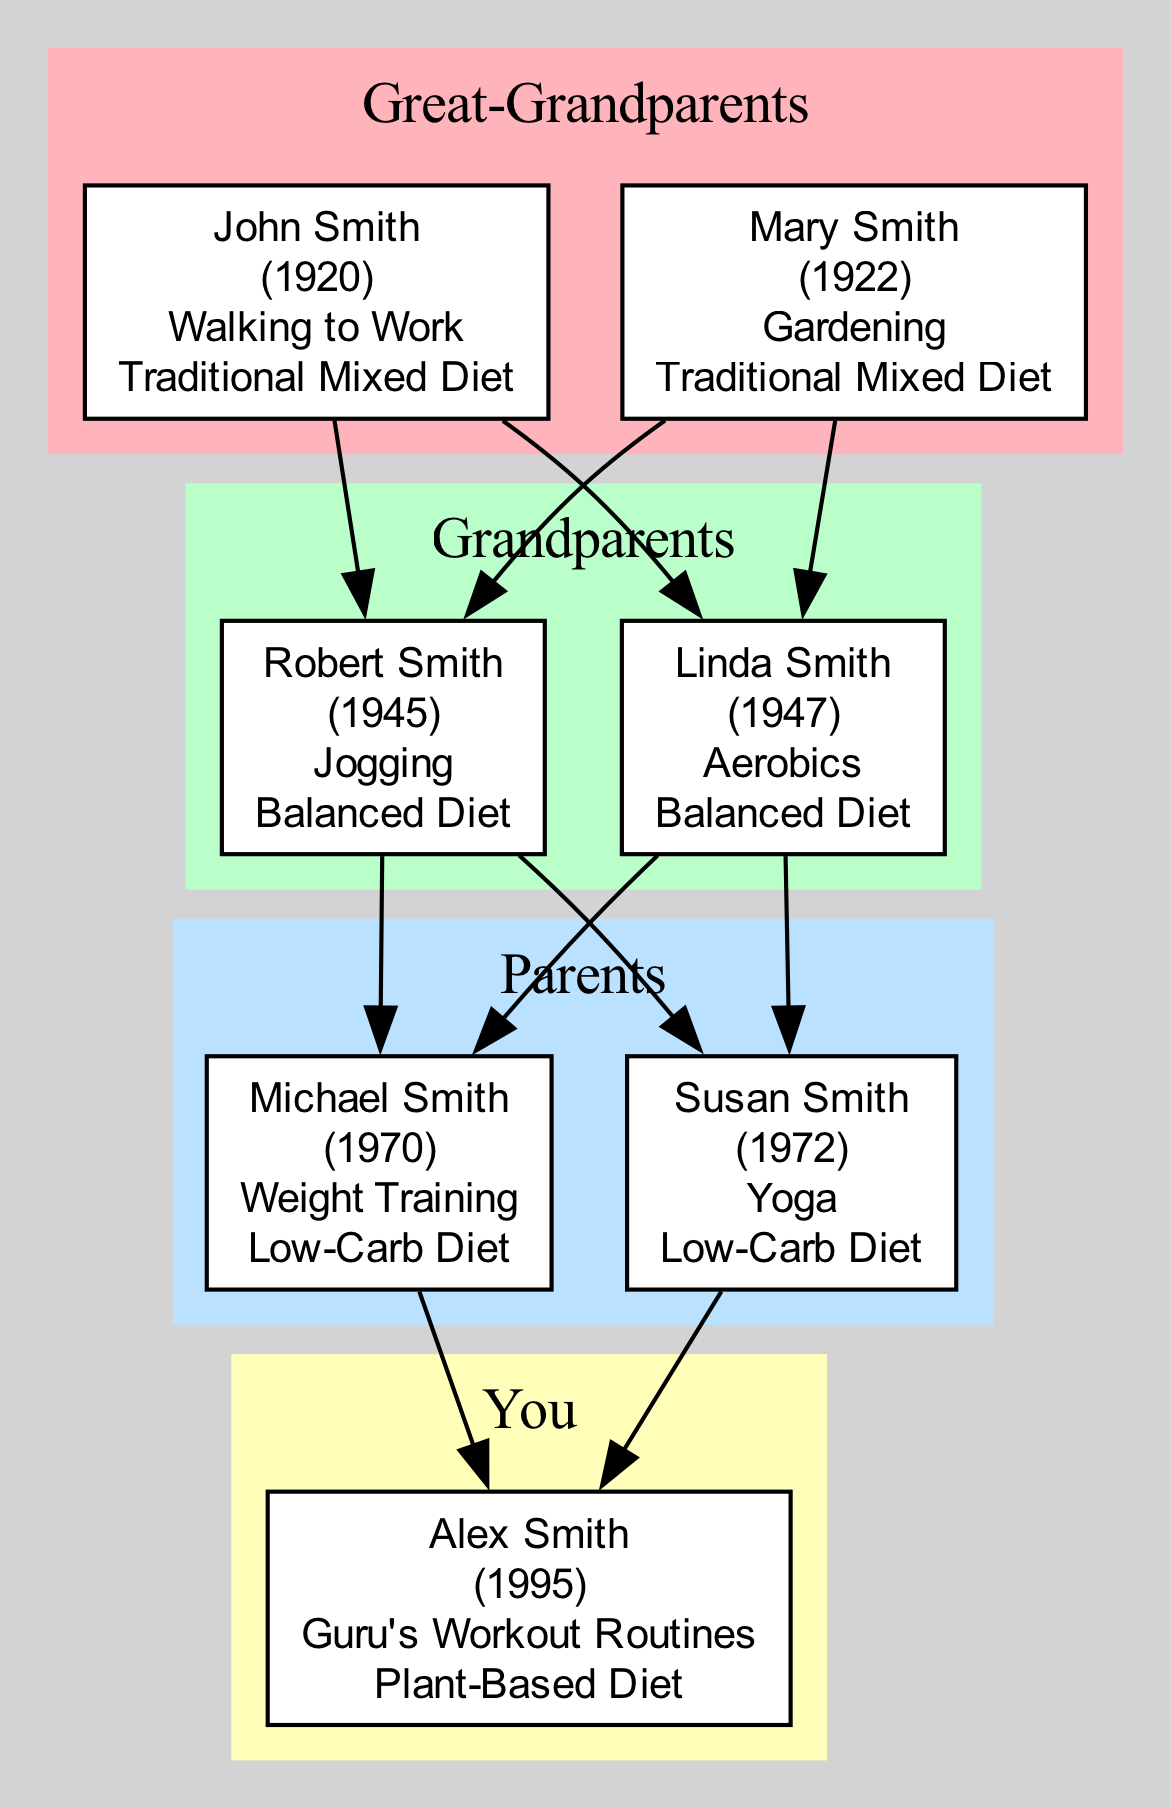What is the physical activity of Mary Smith? Mary's physical activity is listed as "Gardening" in the diagram, which reflects her engagement in that particular physical exercise throughout her life.
Answer: Gardening How many individuals are there in the Grandparents generation? In the Grandparents generation, there are two individuals: Robert Smith and Linda Smith. This can be counted directly from the nodes representing that generation.
Answer: 2 What type of diet did Michael Smith follow? Michael Smith is noted for following a "Low-Carb Diet." This is explicitly stated in his node in the diagram and represents his dietary choice.
Answer: Low-Carb Diet Which generation is Alex Smith part of? Alex Smith belongs to the "You" generation, as specified in the structure of the family tree. This can be verified by locating the corresponding node that represents Alex.
Answer: You What is the relationship between John Smith and Alex Smith? John Smith is Alex Smith's great-grandfather, which means he is two generations above Alex in the family tree. This relationship is indicated by the flow of edges connecting the generations.
Answer: Great-Grandfather Who practiced Yoga in the Parents generation? Susan Smith practiced Yoga, according to her node in the Parents generation within the diagram. This information is directly provided.
Answer: Susan Smith Which individual was born first in the Great-Grandparents generation? John Smith, born in 1920, is the earliest individual in the Great-Grandparents generation, as he has the lowest birth year among the individuals in that generation.
Answer: John Smith What is the dominant diet type among the Parents generation? The Parents generation primarily followed a "Low-Carb Diet," which was chosen by both Michael Smith and Susan Smith in that generation. This is indicated in their respective nodes.
Answer: Low-Carb Diet Which activity is common in the Grandparents generation? The common activity in the Grandparents generation includes both Jogging and Aerobics. Both individuals are noted for their respective activities, which characterize that generation's focus on fitness.
Answer: Jogging and Aerobics 